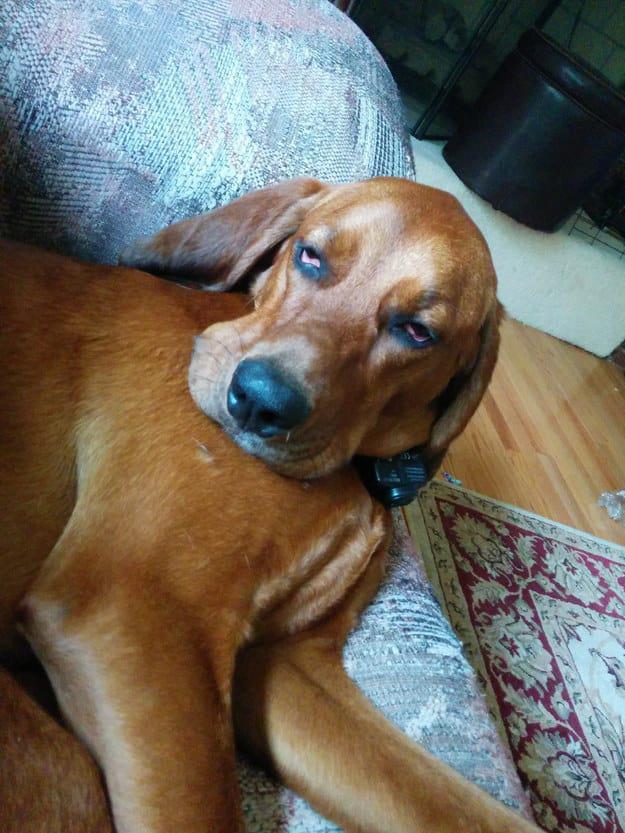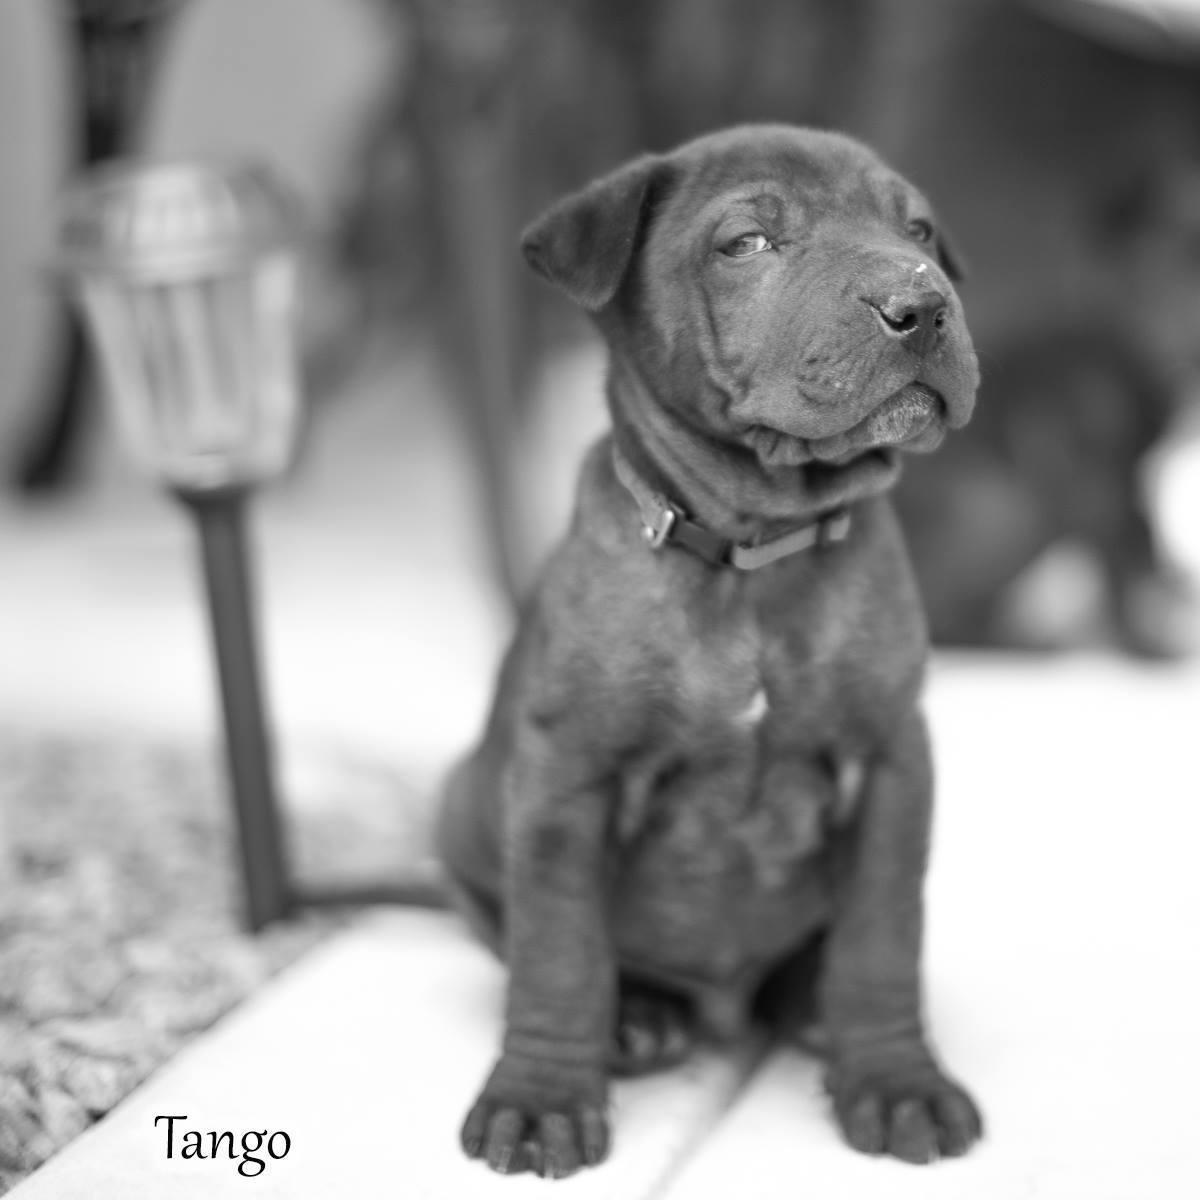The first image is the image on the left, the second image is the image on the right. For the images displayed, is the sentence "In at least one image there is a red hound with a collar sitting in the grass." factually correct? Answer yes or no. No. 